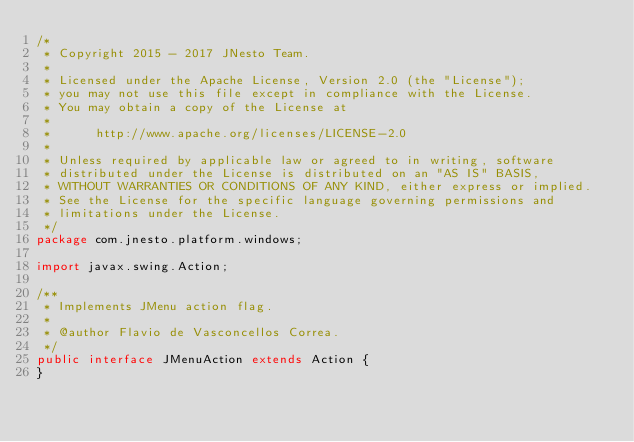Convert code to text. <code><loc_0><loc_0><loc_500><loc_500><_Java_>/*
 * Copyright 2015 - 2017 JNesto Team.
 *
 * Licensed under the Apache License, Version 2.0 (the "License");
 * you may not use this file except in compliance with the License.
 * You may obtain a copy of the License at
 *
 *      http://www.apache.org/licenses/LICENSE-2.0
 *
 * Unless required by applicable law or agreed to in writing, software
 * distributed under the License is distributed on an "AS IS" BASIS,
 * WITHOUT WARRANTIES OR CONDITIONS OF ANY KIND, either express or implied.
 * See the License for the specific language governing permissions and
 * limitations under the License.
 */
package com.jnesto.platform.windows;

import javax.swing.Action;

/**
 * Implements JMenu action flag.
 * 
 * @author Flavio de Vasconcellos Correa.
 */
public interface JMenuAction extends Action {
}
</code> 